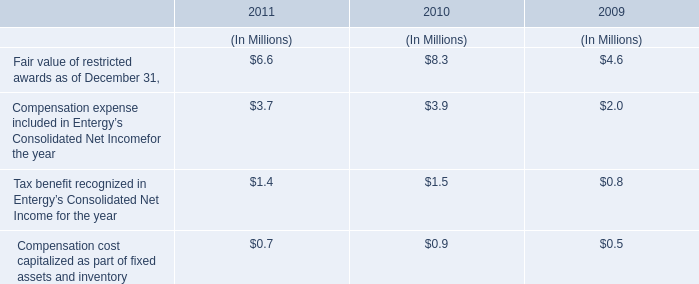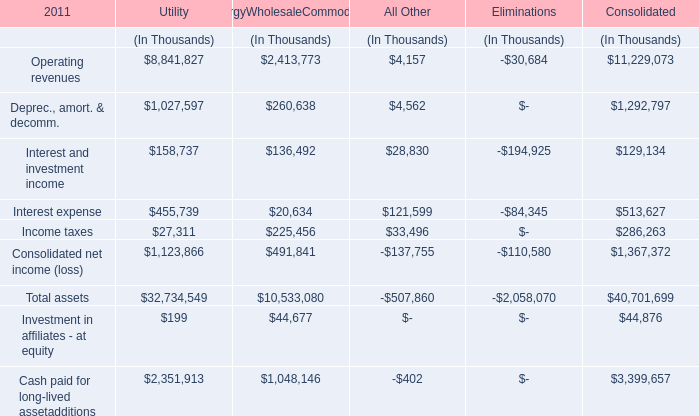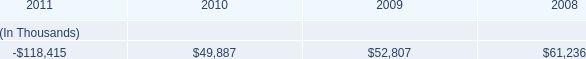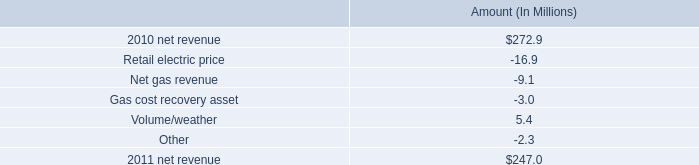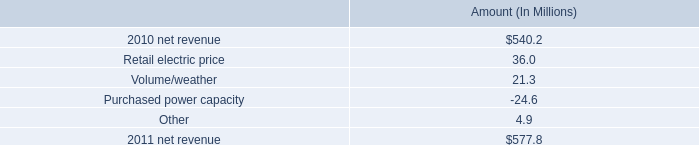in 2010 what was the ratio of the net gas revenue to the gas cost recovery asset ( 3.0 ) 
Computations: (9.1 / 3.0)
Answer: 3.03333. 